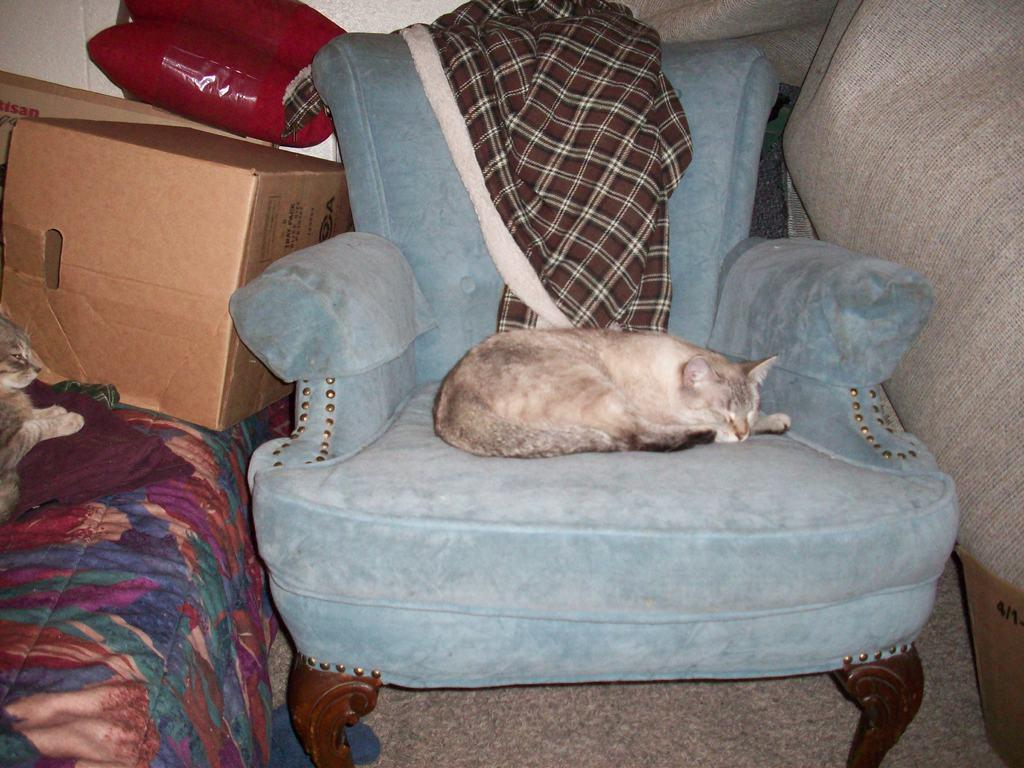What object is present in the image that could be used for storage? There is a box in the image that could be used for storage. What piece of furniture is present in the image that is typically used for sleeping? There is a bed in the image that is typically used for sleeping. What type of animal can be seen in the image, and where is it located? There is a cat on a sofa in the image. Reasoning: Let' Let's think step by step in order to produce the conversation. We start by identifying the main objects in the image, which are the box, bed, and cat on a sofa. Then, we formulate questions that focus on the purpose or location of these objects, ensuring that each question can be answered definitively with the information given. We avoid yes/no questions and ensure that the language is simple and clear. Absurd Question/Answer: What type of cake is being thought about by the cat in the image? There is no cake present in the image, and the cat is not shown to be thinking about anything. 